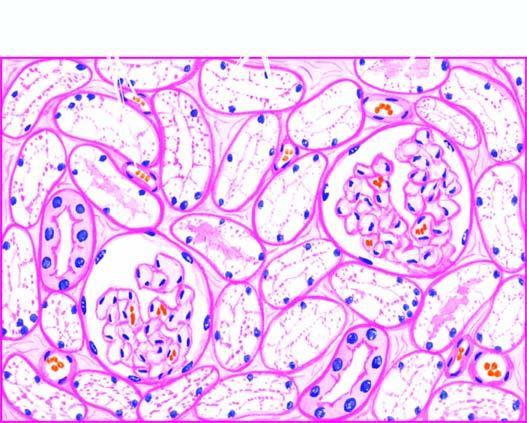what are pale?
Answer the question using a single word or phrase. The nuclei of affected tubules 